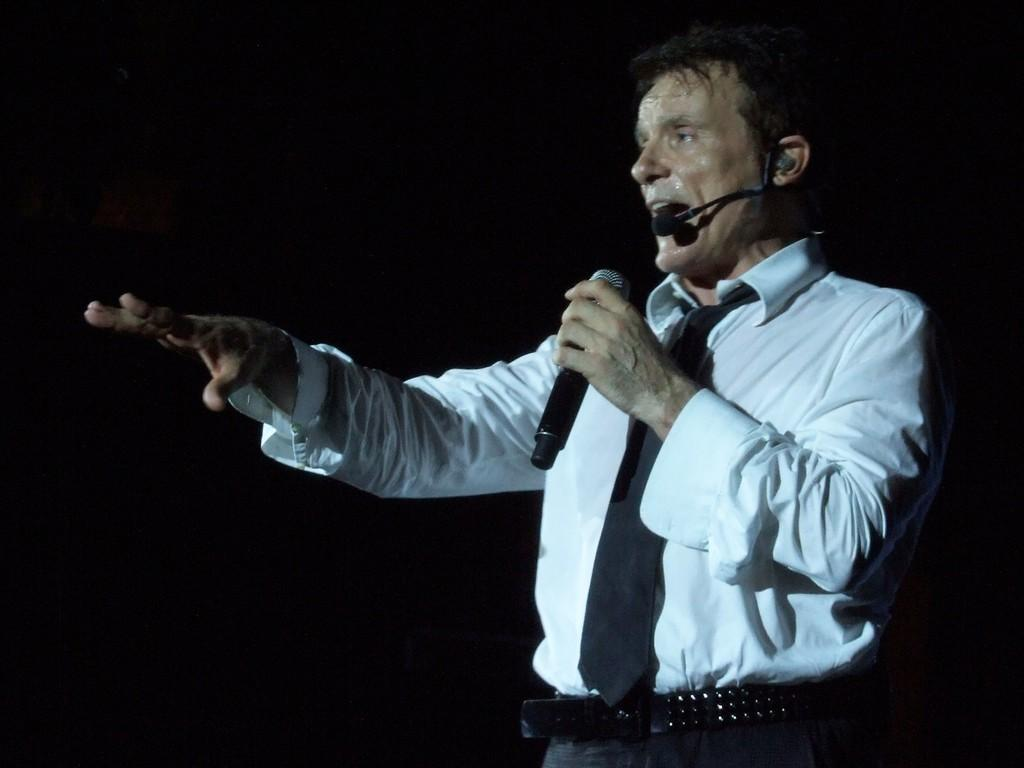What is the main subject of the image? The main subject of the image is a man. What is the man doing in the image? The man is standing in the image. What object is the man holding in the image? The man is holding a mic in the image. Can you see a boat in the image? No, there is no boat present in the image. What part of the man's body is holding the mic? The image does not provide enough detail to determine which part of the man's body is holding the mic. 